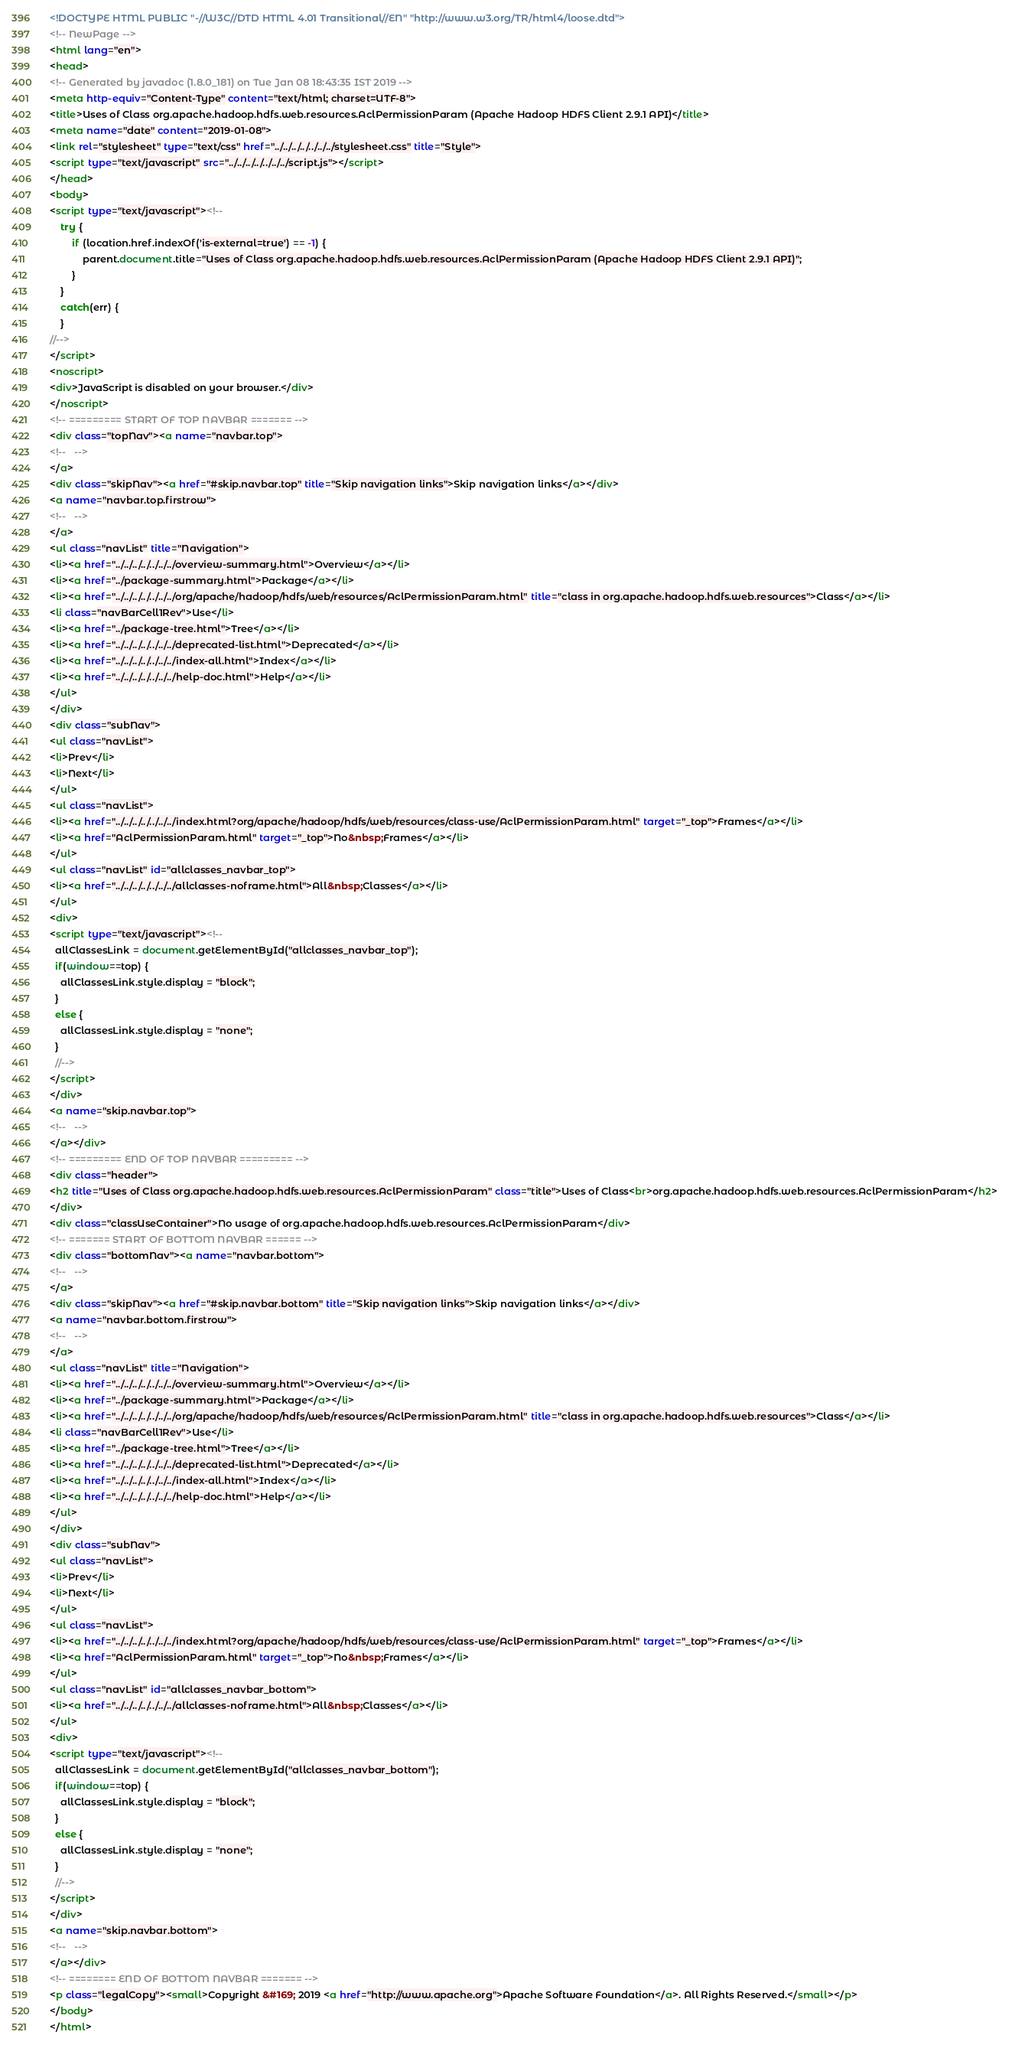<code> <loc_0><loc_0><loc_500><loc_500><_HTML_><!DOCTYPE HTML PUBLIC "-//W3C//DTD HTML 4.01 Transitional//EN" "http://www.w3.org/TR/html4/loose.dtd">
<!-- NewPage -->
<html lang="en">
<head>
<!-- Generated by javadoc (1.8.0_181) on Tue Jan 08 18:43:35 IST 2019 -->
<meta http-equiv="Content-Type" content="text/html; charset=UTF-8">
<title>Uses of Class org.apache.hadoop.hdfs.web.resources.AclPermissionParam (Apache Hadoop HDFS Client 2.9.1 API)</title>
<meta name="date" content="2019-01-08">
<link rel="stylesheet" type="text/css" href="../../../../../../../stylesheet.css" title="Style">
<script type="text/javascript" src="../../../../../../../script.js"></script>
</head>
<body>
<script type="text/javascript"><!--
    try {
        if (location.href.indexOf('is-external=true') == -1) {
            parent.document.title="Uses of Class org.apache.hadoop.hdfs.web.resources.AclPermissionParam (Apache Hadoop HDFS Client 2.9.1 API)";
        }
    }
    catch(err) {
    }
//-->
</script>
<noscript>
<div>JavaScript is disabled on your browser.</div>
</noscript>
<!-- ========= START OF TOP NAVBAR ======= -->
<div class="topNav"><a name="navbar.top">
<!--   -->
</a>
<div class="skipNav"><a href="#skip.navbar.top" title="Skip navigation links">Skip navigation links</a></div>
<a name="navbar.top.firstrow">
<!--   -->
</a>
<ul class="navList" title="Navigation">
<li><a href="../../../../../../../overview-summary.html">Overview</a></li>
<li><a href="../package-summary.html">Package</a></li>
<li><a href="../../../../../../../org/apache/hadoop/hdfs/web/resources/AclPermissionParam.html" title="class in org.apache.hadoop.hdfs.web.resources">Class</a></li>
<li class="navBarCell1Rev">Use</li>
<li><a href="../package-tree.html">Tree</a></li>
<li><a href="../../../../../../../deprecated-list.html">Deprecated</a></li>
<li><a href="../../../../../../../index-all.html">Index</a></li>
<li><a href="../../../../../../../help-doc.html">Help</a></li>
</ul>
</div>
<div class="subNav">
<ul class="navList">
<li>Prev</li>
<li>Next</li>
</ul>
<ul class="navList">
<li><a href="../../../../../../../index.html?org/apache/hadoop/hdfs/web/resources/class-use/AclPermissionParam.html" target="_top">Frames</a></li>
<li><a href="AclPermissionParam.html" target="_top">No&nbsp;Frames</a></li>
</ul>
<ul class="navList" id="allclasses_navbar_top">
<li><a href="../../../../../../../allclasses-noframe.html">All&nbsp;Classes</a></li>
</ul>
<div>
<script type="text/javascript"><!--
  allClassesLink = document.getElementById("allclasses_navbar_top");
  if(window==top) {
    allClassesLink.style.display = "block";
  }
  else {
    allClassesLink.style.display = "none";
  }
  //-->
</script>
</div>
<a name="skip.navbar.top">
<!--   -->
</a></div>
<!-- ========= END OF TOP NAVBAR ========= -->
<div class="header">
<h2 title="Uses of Class org.apache.hadoop.hdfs.web.resources.AclPermissionParam" class="title">Uses of Class<br>org.apache.hadoop.hdfs.web.resources.AclPermissionParam</h2>
</div>
<div class="classUseContainer">No usage of org.apache.hadoop.hdfs.web.resources.AclPermissionParam</div>
<!-- ======= START OF BOTTOM NAVBAR ====== -->
<div class="bottomNav"><a name="navbar.bottom">
<!--   -->
</a>
<div class="skipNav"><a href="#skip.navbar.bottom" title="Skip navigation links">Skip navigation links</a></div>
<a name="navbar.bottom.firstrow">
<!--   -->
</a>
<ul class="navList" title="Navigation">
<li><a href="../../../../../../../overview-summary.html">Overview</a></li>
<li><a href="../package-summary.html">Package</a></li>
<li><a href="../../../../../../../org/apache/hadoop/hdfs/web/resources/AclPermissionParam.html" title="class in org.apache.hadoop.hdfs.web.resources">Class</a></li>
<li class="navBarCell1Rev">Use</li>
<li><a href="../package-tree.html">Tree</a></li>
<li><a href="../../../../../../../deprecated-list.html">Deprecated</a></li>
<li><a href="../../../../../../../index-all.html">Index</a></li>
<li><a href="../../../../../../../help-doc.html">Help</a></li>
</ul>
</div>
<div class="subNav">
<ul class="navList">
<li>Prev</li>
<li>Next</li>
</ul>
<ul class="navList">
<li><a href="../../../../../../../index.html?org/apache/hadoop/hdfs/web/resources/class-use/AclPermissionParam.html" target="_top">Frames</a></li>
<li><a href="AclPermissionParam.html" target="_top">No&nbsp;Frames</a></li>
</ul>
<ul class="navList" id="allclasses_navbar_bottom">
<li><a href="../../../../../../../allclasses-noframe.html">All&nbsp;Classes</a></li>
</ul>
<div>
<script type="text/javascript"><!--
  allClassesLink = document.getElementById("allclasses_navbar_bottom");
  if(window==top) {
    allClassesLink.style.display = "block";
  }
  else {
    allClassesLink.style.display = "none";
  }
  //-->
</script>
</div>
<a name="skip.navbar.bottom">
<!--   -->
</a></div>
<!-- ======== END OF BOTTOM NAVBAR ======= -->
<p class="legalCopy"><small>Copyright &#169; 2019 <a href="http://www.apache.org">Apache Software Foundation</a>. All Rights Reserved.</small></p>
</body>
</html>
</code> 